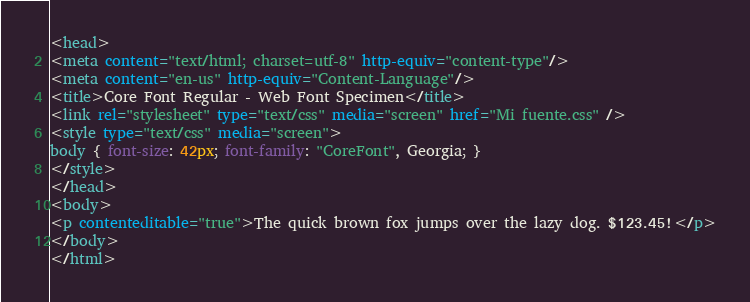<code> <loc_0><loc_0><loc_500><loc_500><_HTML_><head>
<meta content="text/html; charset=utf-8" http-equiv="content-type"/>
<meta content="en-us" http-equiv="Content-Language"/>
<title>Core Font Regular - Web Font Specimen</title>
<link rel="stylesheet" type="text/css" media="screen" href="Mi fuente.css" />
<style type="text/css" media="screen">
body { font-size: 42px; font-family: "CoreFont", Georgia; }
</style>
</head>
<body>
<p contenteditable="true">The quick brown fox jumps over the lazy dog. $123.45!</p>
</body>
</html>
</code> 